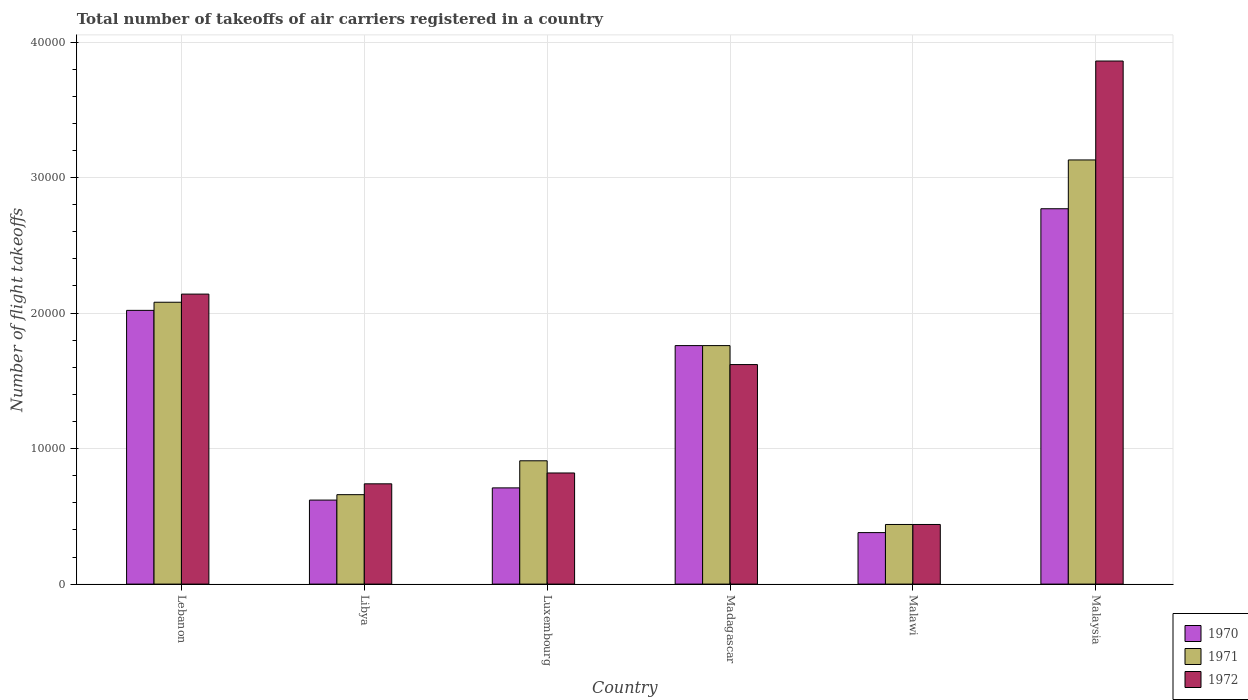Are the number of bars per tick equal to the number of legend labels?
Your answer should be very brief. Yes. Are the number of bars on each tick of the X-axis equal?
Your response must be concise. Yes. How many bars are there on the 3rd tick from the left?
Provide a succinct answer. 3. What is the label of the 6th group of bars from the left?
Your answer should be very brief. Malaysia. In how many cases, is the number of bars for a given country not equal to the number of legend labels?
Ensure brevity in your answer.  0. What is the total number of flight takeoffs in 1972 in Madagascar?
Provide a succinct answer. 1.62e+04. Across all countries, what is the maximum total number of flight takeoffs in 1971?
Give a very brief answer. 3.13e+04. Across all countries, what is the minimum total number of flight takeoffs in 1970?
Provide a succinct answer. 3800. In which country was the total number of flight takeoffs in 1971 maximum?
Offer a terse response. Malaysia. In which country was the total number of flight takeoffs in 1970 minimum?
Provide a succinct answer. Malawi. What is the total total number of flight takeoffs in 1972 in the graph?
Keep it short and to the point. 9.62e+04. What is the difference between the total number of flight takeoffs in 1971 in Madagascar and that in Malawi?
Ensure brevity in your answer.  1.32e+04. What is the difference between the total number of flight takeoffs in 1971 in Luxembourg and the total number of flight takeoffs in 1972 in Malawi?
Your response must be concise. 4700. What is the average total number of flight takeoffs in 1971 per country?
Offer a terse response. 1.50e+04. What is the difference between the total number of flight takeoffs of/in 1970 and total number of flight takeoffs of/in 1972 in Malaysia?
Give a very brief answer. -1.09e+04. In how many countries, is the total number of flight takeoffs in 1972 greater than 34000?
Make the answer very short. 1. What is the ratio of the total number of flight takeoffs in 1970 in Malawi to that in Malaysia?
Provide a short and direct response. 0.14. What is the difference between the highest and the second highest total number of flight takeoffs in 1971?
Provide a short and direct response. -1.05e+04. What is the difference between the highest and the lowest total number of flight takeoffs in 1972?
Give a very brief answer. 3.42e+04. What does the 1st bar from the right in Luxembourg represents?
Your answer should be very brief. 1972. Is it the case that in every country, the sum of the total number of flight takeoffs in 1972 and total number of flight takeoffs in 1970 is greater than the total number of flight takeoffs in 1971?
Provide a short and direct response. Yes. How many bars are there?
Ensure brevity in your answer.  18. Are all the bars in the graph horizontal?
Give a very brief answer. No. What is the difference between two consecutive major ticks on the Y-axis?
Offer a terse response. 10000. Are the values on the major ticks of Y-axis written in scientific E-notation?
Your response must be concise. No. How many legend labels are there?
Keep it short and to the point. 3. How are the legend labels stacked?
Provide a succinct answer. Vertical. What is the title of the graph?
Your answer should be very brief. Total number of takeoffs of air carriers registered in a country. What is the label or title of the X-axis?
Offer a very short reply. Country. What is the label or title of the Y-axis?
Provide a succinct answer. Number of flight takeoffs. What is the Number of flight takeoffs of 1970 in Lebanon?
Your response must be concise. 2.02e+04. What is the Number of flight takeoffs of 1971 in Lebanon?
Ensure brevity in your answer.  2.08e+04. What is the Number of flight takeoffs in 1972 in Lebanon?
Your response must be concise. 2.14e+04. What is the Number of flight takeoffs in 1970 in Libya?
Ensure brevity in your answer.  6200. What is the Number of flight takeoffs in 1971 in Libya?
Provide a short and direct response. 6600. What is the Number of flight takeoffs in 1972 in Libya?
Your response must be concise. 7400. What is the Number of flight takeoffs of 1970 in Luxembourg?
Make the answer very short. 7100. What is the Number of flight takeoffs in 1971 in Luxembourg?
Offer a terse response. 9100. What is the Number of flight takeoffs in 1972 in Luxembourg?
Offer a terse response. 8200. What is the Number of flight takeoffs of 1970 in Madagascar?
Make the answer very short. 1.76e+04. What is the Number of flight takeoffs of 1971 in Madagascar?
Offer a very short reply. 1.76e+04. What is the Number of flight takeoffs of 1972 in Madagascar?
Your answer should be compact. 1.62e+04. What is the Number of flight takeoffs in 1970 in Malawi?
Provide a succinct answer. 3800. What is the Number of flight takeoffs of 1971 in Malawi?
Provide a short and direct response. 4400. What is the Number of flight takeoffs of 1972 in Malawi?
Offer a terse response. 4400. What is the Number of flight takeoffs in 1970 in Malaysia?
Provide a short and direct response. 2.77e+04. What is the Number of flight takeoffs of 1971 in Malaysia?
Keep it short and to the point. 3.13e+04. What is the Number of flight takeoffs in 1972 in Malaysia?
Provide a succinct answer. 3.86e+04. Across all countries, what is the maximum Number of flight takeoffs of 1970?
Give a very brief answer. 2.77e+04. Across all countries, what is the maximum Number of flight takeoffs in 1971?
Your answer should be compact. 3.13e+04. Across all countries, what is the maximum Number of flight takeoffs of 1972?
Make the answer very short. 3.86e+04. Across all countries, what is the minimum Number of flight takeoffs of 1970?
Your answer should be very brief. 3800. Across all countries, what is the minimum Number of flight takeoffs of 1971?
Ensure brevity in your answer.  4400. Across all countries, what is the minimum Number of flight takeoffs in 1972?
Your answer should be compact. 4400. What is the total Number of flight takeoffs of 1970 in the graph?
Offer a terse response. 8.26e+04. What is the total Number of flight takeoffs of 1971 in the graph?
Offer a very short reply. 8.98e+04. What is the total Number of flight takeoffs in 1972 in the graph?
Keep it short and to the point. 9.62e+04. What is the difference between the Number of flight takeoffs in 1970 in Lebanon and that in Libya?
Your answer should be compact. 1.40e+04. What is the difference between the Number of flight takeoffs of 1971 in Lebanon and that in Libya?
Provide a short and direct response. 1.42e+04. What is the difference between the Number of flight takeoffs of 1972 in Lebanon and that in Libya?
Your answer should be compact. 1.40e+04. What is the difference between the Number of flight takeoffs in 1970 in Lebanon and that in Luxembourg?
Give a very brief answer. 1.31e+04. What is the difference between the Number of flight takeoffs in 1971 in Lebanon and that in Luxembourg?
Provide a short and direct response. 1.17e+04. What is the difference between the Number of flight takeoffs in 1972 in Lebanon and that in Luxembourg?
Give a very brief answer. 1.32e+04. What is the difference between the Number of flight takeoffs in 1970 in Lebanon and that in Madagascar?
Keep it short and to the point. 2600. What is the difference between the Number of flight takeoffs in 1971 in Lebanon and that in Madagascar?
Ensure brevity in your answer.  3200. What is the difference between the Number of flight takeoffs of 1972 in Lebanon and that in Madagascar?
Offer a terse response. 5200. What is the difference between the Number of flight takeoffs in 1970 in Lebanon and that in Malawi?
Offer a terse response. 1.64e+04. What is the difference between the Number of flight takeoffs in 1971 in Lebanon and that in Malawi?
Your answer should be compact. 1.64e+04. What is the difference between the Number of flight takeoffs of 1972 in Lebanon and that in Malawi?
Offer a terse response. 1.70e+04. What is the difference between the Number of flight takeoffs in 1970 in Lebanon and that in Malaysia?
Keep it short and to the point. -7500. What is the difference between the Number of flight takeoffs of 1971 in Lebanon and that in Malaysia?
Offer a terse response. -1.05e+04. What is the difference between the Number of flight takeoffs in 1972 in Lebanon and that in Malaysia?
Keep it short and to the point. -1.72e+04. What is the difference between the Number of flight takeoffs in 1970 in Libya and that in Luxembourg?
Make the answer very short. -900. What is the difference between the Number of flight takeoffs in 1971 in Libya and that in Luxembourg?
Your response must be concise. -2500. What is the difference between the Number of flight takeoffs in 1972 in Libya and that in Luxembourg?
Offer a terse response. -800. What is the difference between the Number of flight takeoffs of 1970 in Libya and that in Madagascar?
Your answer should be compact. -1.14e+04. What is the difference between the Number of flight takeoffs in 1971 in Libya and that in Madagascar?
Offer a terse response. -1.10e+04. What is the difference between the Number of flight takeoffs in 1972 in Libya and that in Madagascar?
Provide a succinct answer. -8800. What is the difference between the Number of flight takeoffs of 1970 in Libya and that in Malawi?
Make the answer very short. 2400. What is the difference between the Number of flight takeoffs of 1971 in Libya and that in Malawi?
Your response must be concise. 2200. What is the difference between the Number of flight takeoffs in 1972 in Libya and that in Malawi?
Provide a short and direct response. 3000. What is the difference between the Number of flight takeoffs of 1970 in Libya and that in Malaysia?
Offer a very short reply. -2.15e+04. What is the difference between the Number of flight takeoffs of 1971 in Libya and that in Malaysia?
Your answer should be compact. -2.47e+04. What is the difference between the Number of flight takeoffs in 1972 in Libya and that in Malaysia?
Your answer should be compact. -3.12e+04. What is the difference between the Number of flight takeoffs of 1970 in Luxembourg and that in Madagascar?
Your answer should be compact. -1.05e+04. What is the difference between the Number of flight takeoffs of 1971 in Luxembourg and that in Madagascar?
Make the answer very short. -8500. What is the difference between the Number of flight takeoffs in 1972 in Luxembourg and that in Madagascar?
Provide a succinct answer. -8000. What is the difference between the Number of flight takeoffs of 1970 in Luxembourg and that in Malawi?
Your response must be concise. 3300. What is the difference between the Number of flight takeoffs in 1971 in Luxembourg and that in Malawi?
Provide a short and direct response. 4700. What is the difference between the Number of flight takeoffs in 1972 in Luxembourg and that in Malawi?
Offer a very short reply. 3800. What is the difference between the Number of flight takeoffs in 1970 in Luxembourg and that in Malaysia?
Give a very brief answer. -2.06e+04. What is the difference between the Number of flight takeoffs in 1971 in Luxembourg and that in Malaysia?
Give a very brief answer. -2.22e+04. What is the difference between the Number of flight takeoffs in 1972 in Luxembourg and that in Malaysia?
Provide a short and direct response. -3.04e+04. What is the difference between the Number of flight takeoffs in 1970 in Madagascar and that in Malawi?
Offer a terse response. 1.38e+04. What is the difference between the Number of flight takeoffs of 1971 in Madagascar and that in Malawi?
Provide a succinct answer. 1.32e+04. What is the difference between the Number of flight takeoffs in 1972 in Madagascar and that in Malawi?
Provide a short and direct response. 1.18e+04. What is the difference between the Number of flight takeoffs of 1970 in Madagascar and that in Malaysia?
Provide a succinct answer. -1.01e+04. What is the difference between the Number of flight takeoffs of 1971 in Madagascar and that in Malaysia?
Offer a very short reply. -1.37e+04. What is the difference between the Number of flight takeoffs of 1972 in Madagascar and that in Malaysia?
Offer a very short reply. -2.24e+04. What is the difference between the Number of flight takeoffs of 1970 in Malawi and that in Malaysia?
Keep it short and to the point. -2.39e+04. What is the difference between the Number of flight takeoffs in 1971 in Malawi and that in Malaysia?
Provide a succinct answer. -2.69e+04. What is the difference between the Number of flight takeoffs in 1972 in Malawi and that in Malaysia?
Your answer should be compact. -3.42e+04. What is the difference between the Number of flight takeoffs in 1970 in Lebanon and the Number of flight takeoffs in 1971 in Libya?
Your response must be concise. 1.36e+04. What is the difference between the Number of flight takeoffs in 1970 in Lebanon and the Number of flight takeoffs in 1972 in Libya?
Provide a short and direct response. 1.28e+04. What is the difference between the Number of flight takeoffs of 1971 in Lebanon and the Number of flight takeoffs of 1972 in Libya?
Your answer should be compact. 1.34e+04. What is the difference between the Number of flight takeoffs in 1970 in Lebanon and the Number of flight takeoffs in 1971 in Luxembourg?
Offer a very short reply. 1.11e+04. What is the difference between the Number of flight takeoffs in 1970 in Lebanon and the Number of flight takeoffs in 1972 in Luxembourg?
Offer a very short reply. 1.20e+04. What is the difference between the Number of flight takeoffs of 1971 in Lebanon and the Number of flight takeoffs of 1972 in Luxembourg?
Your answer should be very brief. 1.26e+04. What is the difference between the Number of flight takeoffs of 1970 in Lebanon and the Number of flight takeoffs of 1971 in Madagascar?
Keep it short and to the point. 2600. What is the difference between the Number of flight takeoffs of 1970 in Lebanon and the Number of flight takeoffs of 1972 in Madagascar?
Your response must be concise. 4000. What is the difference between the Number of flight takeoffs in 1971 in Lebanon and the Number of flight takeoffs in 1972 in Madagascar?
Your answer should be very brief. 4600. What is the difference between the Number of flight takeoffs in 1970 in Lebanon and the Number of flight takeoffs in 1971 in Malawi?
Offer a very short reply. 1.58e+04. What is the difference between the Number of flight takeoffs in 1970 in Lebanon and the Number of flight takeoffs in 1972 in Malawi?
Your answer should be very brief. 1.58e+04. What is the difference between the Number of flight takeoffs in 1971 in Lebanon and the Number of flight takeoffs in 1972 in Malawi?
Your response must be concise. 1.64e+04. What is the difference between the Number of flight takeoffs of 1970 in Lebanon and the Number of flight takeoffs of 1971 in Malaysia?
Your response must be concise. -1.11e+04. What is the difference between the Number of flight takeoffs in 1970 in Lebanon and the Number of flight takeoffs in 1972 in Malaysia?
Keep it short and to the point. -1.84e+04. What is the difference between the Number of flight takeoffs of 1971 in Lebanon and the Number of flight takeoffs of 1972 in Malaysia?
Provide a succinct answer. -1.78e+04. What is the difference between the Number of flight takeoffs in 1970 in Libya and the Number of flight takeoffs in 1971 in Luxembourg?
Provide a succinct answer. -2900. What is the difference between the Number of flight takeoffs in 1970 in Libya and the Number of flight takeoffs in 1972 in Luxembourg?
Offer a very short reply. -2000. What is the difference between the Number of flight takeoffs in 1971 in Libya and the Number of flight takeoffs in 1972 in Luxembourg?
Give a very brief answer. -1600. What is the difference between the Number of flight takeoffs of 1970 in Libya and the Number of flight takeoffs of 1971 in Madagascar?
Make the answer very short. -1.14e+04. What is the difference between the Number of flight takeoffs in 1970 in Libya and the Number of flight takeoffs in 1972 in Madagascar?
Give a very brief answer. -10000. What is the difference between the Number of flight takeoffs in 1971 in Libya and the Number of flight takeoffs in 1972 in Madagascar?
Keep it short and to the point. -9600. What is the difference between the Number of flight takeoffs in 1970 in Libya and the Number of flight takeoffs in 1971 in Malawi?
Provide a succinct answer. 1800. What is the difference between the Number of flight takeoffs in 1970 in Libya and the Number of flight takeoffs in 1972 in Malawi?
Provide a succinct answer. 1800. What is the difference between the Number of flight takeoffs of 1971 in Libya and the Number of flight takeoffs of 1972 in Malawi?
Your answer should be very brief. 2200. What is the difference between the Number of flight takeoffs of 1970 in Libya and the Number of flight takeoffs of 1971 in Malaysia?
Make the answer very short. -2.51e+04. What is the difference between the Number of flight takeoffs of 1970 in Libya and the Number of flight takeoffs of 1972 in Malaysia?
Offer a very short reply. -3.24e+04. What is the difference between the Number of flight takeoffs of 1971 in Libya and the Number of flight takeoffs of 1972 in Malaysia?
Your answer should be compact. -3.20e+04. What is the difference between the Number of flight takeoffs in 1970 in Luxembourg and the Number of flight takeoffs in 1971 in Madagascar?
Provide a succinct answer. -1.05e+04. What is the difference between the Number of flight takeoffs of 1970 in Luxembourg and the Number of flight takeoffs of 1972 in Madagascar?
Offer a terse response. -9100. What is the difference between the Number of flight takeoffs in 1971 in Luxembourg and the Number of flight takeoffs in 1972 in Madagascar?
Your answer should be very brief. -7100. What is the difference between the Number of flight takeoffs of 1970 in Luxembourg and the Number of flight takeoffs of 1971 in Malawi?
Ensure brevity in your answer.  2700. What is the difference between the Number of flight takeoffs in 1970 in Luxembourg and the Number of flight takeoffs in 1972 in Malawi?
Provide a short and direct response. 2700. What is the difference between the Number of flight takeoffs in 1971 in Luxembourg and the Number of flight takeoffs in 1972 in Malawi?
Your answer should be compact. 4700. What is the difference between the Number of flight takeoffs in 1970 in Luxembourg and the Number of flight takeoffs in 1971 in Malaysia?
Provide a short and direct response. -2.42e+04. What is the difference between the Number of flight takeoffs in 1970 in Luxembourg and the Number of flight takeoffs in 1972 in Malaysia?
Offer a terse response. -3.15e+04. What is the difference between the Number of flight takeoffs of 1971 in Luxembourg and the Number of flight takeoffs of 1972 in Malaysia?
Provide a succinct answer. -2.95e+04. What is the difference between the Number of flight takeoffs of 1970 in Madagascar and the Number of flight takeoffs of 1971 in Malawi?
Provide a short and direct response. 1.32e+04. What is the difference between the Number of flight takeoffs in 1970 in Madagascar and the Number of flight takeoffs in 1972 in Malawi?
Ensure brevity in your answer.  1.32e+04. What is the difference between the Number of flight takeoffs of 1971 in Madagascar and the Number of flight takeoffs of 1972 in Malawi?
Ensure brevity in your answer.  1.32e+04. What is the difference between the Number of flight takeoffs of 1970 in Madagascar and the Number of flight takeoffs of 1971 in Malaysia?
Provide a short and direct response. -1.37e+04. What is the difference between the Number of flight takeoffs in 1970 in Madagascar and the Number of flight takeoffs in 1972 in Malaysia?
Provide a succinct answer. -2.10e+04. What is the difference between the Number of flight takeoffs of 1971 in Madagascar and the Number of flight takeoffs of 1972 in Malaysia?
Give a very brief answer. -2.10e+04. What is the difference between the Number of flight takeoffs of 1970 in Malawi and the Number of flight takeoffs of 1971 in Malaysia?
Your answer should be compact. -2.75e+04. What is the difference between the Number of flight takeoffs of 1970 in Malawi and the Number of flight takeoffs of 1972 in Malaysia?
Ensure brevity in your answer.  -3.48e+04. What is the difference between the Number of flight takeoffs in 1971 in Malawi and the Number of flight takeoffs in 1972 in Malaysia?
Give a very brief answer. -3.42e+04. What is the average Number of flight takeoffs in 1970 per country?
Ensure brevity in your answer.  1.38e+04. What is the average Number of flight takeoffs of 1971 per country?
Offer a very short reply. 1.50e+04. What is the average Number of flight takeoffs in 1972 per country?
Your answer should be compact. 1.60e+04. What is the difference between the Number of flight takeoffs in 1970 and Number of flight takeoffs in 1971 in Lebanon?
Make the answer very short. -600. What is the difference between the Number of flight takeoffs of 1970 and Number of flight takeoffs of 1972 in Lebanon?
Keep it short and to the point. -1200. What is the difference between the Number of flight takeoffs of 1971 and Number of flight takeoffs of 1972 in Lebanon?
Offer a terse response. -600. What is the difference between the Number of flight takeoffs in 1970 and Number of flight takeoffs in 1971 in Libya?
Make the answer very short. -400. What is the difference between the Number of flight takeoffs in 1970 and Number of flight takeoffs in 1972 in Libya?
Your answer should be very brief. -1200. What is the difference between the Number of flight takeoffs of 1971 and Number of flight takeoffs of 1972 in Libya?
Your answer should be compact. -800. What is the difference between the Number of flight takeoffs in 1970 and Number of flight takeoffs in 1971 in Luxembourg?
Offer a terse response. -2000. What is the difference between the Number of flight takeoffs of 1970 and Number of flight takeoffs of 1972 in Luxembourg?
Your response must be concise. -1100. What is the difference between the Number of flight takeoffs of 1971 and Number of flight takeoffs of 1972 in Luxembourg?
Your answer should be compact. 900. What is the difference between the Number of flight takeoffs of 1970 and Number of flight takeoffs of 1972 in Madagascar?
Provide a succinct answer. 1400. What is the difference between the Number of flight takeoffs of 1971 and Number of flight takeoffs of 1972 in Madagascar?
Ensure brevity in your answer.  1400. What is the difference between the Number of flight takeoffs in 1970 and Number of flight takeoffs in 1971 in Malawi?
Your answer should be very brief. -600. What is the difference between the Number of flight takeoffs of 1970 and Number of flight takeoffs of 1972 in Malawi?
Keep it short and to the point. -600. What is the difference between the Number of flight takeoffs in 1971 and Number of flight takeoffs in 1972 in Malawi?
Your answer should be very brief. 0. What is the difference between the Number of flight takeoffs of 1970 and Number of flight takeoffs of 1971 in Malaysia?
Provide a succinct answer. -3600. What is the difference between the Number of flight takeoffs in 1970 and Number of flight takeoffs in 1972 in Malaysia?
Keep it short and to the point. -1.09e+04. What is the difference between the Number of flight takeoffs in 1971 and Number of flight takeoffs in 1972 in Malaysia?
Offer a terse response. -7300. What is the ratio of the Number of flight takeoffs of 1970 in Lebanon to that in Libya?
Your response must be concise. 3.26. What is the ratio of the Number of flight takeoffs of 1971 in Lebanon to that in Libya?
Your answer should be compact. 3.15. What is the ratio of the Number of flight takeoffs of 1972 in Lebanon to that in Libya?
Your answer should be compact. 2.89. What is the ratio of the Number of flight takeoffs of 1970 in Lebanon to that in Luxembourg?
Your answer should be compact. 2.85. What is the ratio of the Number of flight takeoffs of 1971 in Lebanon to that in Luxembourg?
Give a very brief answer. 2.29. What is the ratio of the Number of flight takeoffs in 1972 in Lebanon to that in Luxembourg?
Provide a short and direct response. 2.61. What is the ratio of the Number of flight takeoffs in 1970 in Lebanon to that in Madagascar?
Make the answer very short. 1.15. What is the ratio of the Number of flight takeoffs of 1971 in Lebanon to that in Madagascar?
Give a very brief answer. 1.18. What is the ratio of the Number of flight takeoffs of 1972 in Lebanon to that in Madagascar?
Provide a short and direct response. 1.32. What is the ratio of the Number of flight takeoffs of 1970 in Lebanon to that in Malawi?
Keep it short and to the point. 5.32. What is the ratio of the Number of flight takeoffs in 1971 in Lebanon to that in Malawi?
Provide a succinct answer. 4.73. What is the ratio of the Number of flight takeoffs in 1972 in Lebanon to that in Malawi?
Your answer should be very brief. 4.86. What is the ratio of the Number of flight takeoffs in 1970 in Lebanon to that in Malaysia?
Your answer should be very brief. 0.73. What is the ratio of the Number of flight takeoffs of 1971 in Lebanon to that in Malaysia?
Offer a terse response. 0.66. What is the ratio of the Number of flight takeoffs in 1972 in Lebanon to that in Malaysia?
Make the answer very short. 0.55. What is the ratio of the Number of flight takeoffs in 1970 in Libya to that in Luxembourg?
Your answer should be compact. 0.87. What is the ratio of the Number of flight takeoffs of 1971 in Libya to that in Luxembourg?
Make the answer very short. 0.73. What is the ratio of the Number of flight takeoffs of 1972 in Libya to that in Luxembourg?
Make the answer very short. 0.9. What is the ratio of the Number of flight takeoffs in 1970 in Libya to that in Madagascar?
Offer a terse response. 0.35. What is the ratio of the Number of flight takeoffs of 1971 in Libya to that in Madagascar?
Keep it short and to the point. 0.38. What is the ratio of the Number of flight takeoffs in 1972 in Libya to that in Madagascar?
Provide a short and direct response. 0.46. What is the ratio of the Number of flight takeoffs of 1970 in Libya to that in Malawi?
Keep it short and to the point. 1.63. What is the ratio of the Number of flight takeoffs of 1971 in Libya to that in Malawi?
Your answer should be compact. 1.5. What is the ratio of the Number of flight takeoffs in 1972 in Libya to that in Malawi?
Make the answer very short. 1.68. What is the ratio of the Number of flight takeoffs in 1970 in Libya to that in Malaysia?
Make the answer very short. 0.22. What is the ratio of the Number of flight takeoffs in 1971 in Libya to that in Malaysia?
Make the answer very short. 0.21. What is the ratio of the Number of flight takeoffs in 1972 in Libya to that in Malaysia?
Offer a terse response. 0.19. What is the ratio of the Number of flight takeoffs of 1970 in Luxembourg to that in Madagascar?
Offer a terse response. 0.4. What is the ratio of the Number of flight takeoffs of 1971 in Luxembourg to that in Madagascar?
Make the answer very short. 0.52. What is the ratio of the Number of flight takeoffs of 1972 in Luxembourg to that in Madagascar?
Give a very brief answer. 0.51. What is the ratio of the Number of flight takeoffs in 1970 in Luxembourg to that in Malawi?
Ensure brevity in your answer.  1.87. What is the ratio of the Number of flight takeoffs of 1971 in Luxembourg to that in Malawi?
Provide a succinct answer. 2.07. What is the ratio of the Number of flight takeoffs of 1972 in Luxembourg to that in Malawi?
Offer a terse response. 1.86. What is the ratio of the Number of flight takeoffs of 1970 in Luxembourg to that in Malaysia?
Keep it short and to the point. 0.26. What is the ratio of the Number of flight takeoffs of 1971 in Luxembourg to that in Malaysia?
Provide a short and direct response. 0.29. What is the ratio of the Number of flight takeoffs in 1972 in Luxembourg to that in Malaysia?
Keep it short and to the point. 0.21. What is the ratio of the Number of flight takeoffs of 1970 in Madagascar to that in Malawi?
Give a very brief answer. 4.63. What is the ratio of the Number of flight takeoffs in 1971 in Madagascar to that in Malawi?
Keep it short and to the point. 4. What is the ratio of the Number of flight takeoffs in 1972 in Madagascar to that in Malawi?
Your response must be concise. 3.68. What is the ratio of the Number of flight takeoffs of 1970 in Madagascar to that in Malaysia?
Offer a terse response. 0.64. What is the ratio of the Number of flight takeoffs of 1971 in Madagascar to that in Malaysia?
Your response must be concise. 0.56. What is the ratio of the Number of flight takeoffs of 1972 in Madagascar to that in Malaysia?
Ensure brevity in your answer.  0.42. What is the ratio of the Number of flight takeoffs of 1970 in Malawi to that in Malaysia?
Ensure brevity in your answer.  0.14. What is the ratio of the Number of flight takeoffs in 1971 in Malawi to that in Malaysia?
Make the answer very short. 0.14. What is the ratio of the Number of flight takeoffs in 1972 in Malawi to that in Malaysia?
Your response must be concise. 0.11. What is the difference between the highest and the second highest Number of flight takeoffs in 1970?
Provide a succinct answer. 7500. What is the difference between the highest and the second highest Number of flight takeoffs of 1971?
Your answer should be compact. 1.05e+04. What is the difference between the highest and the second highest Number of flight takeoffs in 1972?
Offer a terse response. 1.72e+04. What is the difference between the highest and the lowest Number of flight takeoffs in 1970?
Keep it short and to the point. 2.39e+04. What is the difference between the highest and the lowest Number of flight takeoffs in 1971?
Ensure brevity in your answer.  2.69e+04. What is the difference between the highest and the lowest Number of flight takeoffs in 1972?
Make the answer very short. 3.42e+04. 